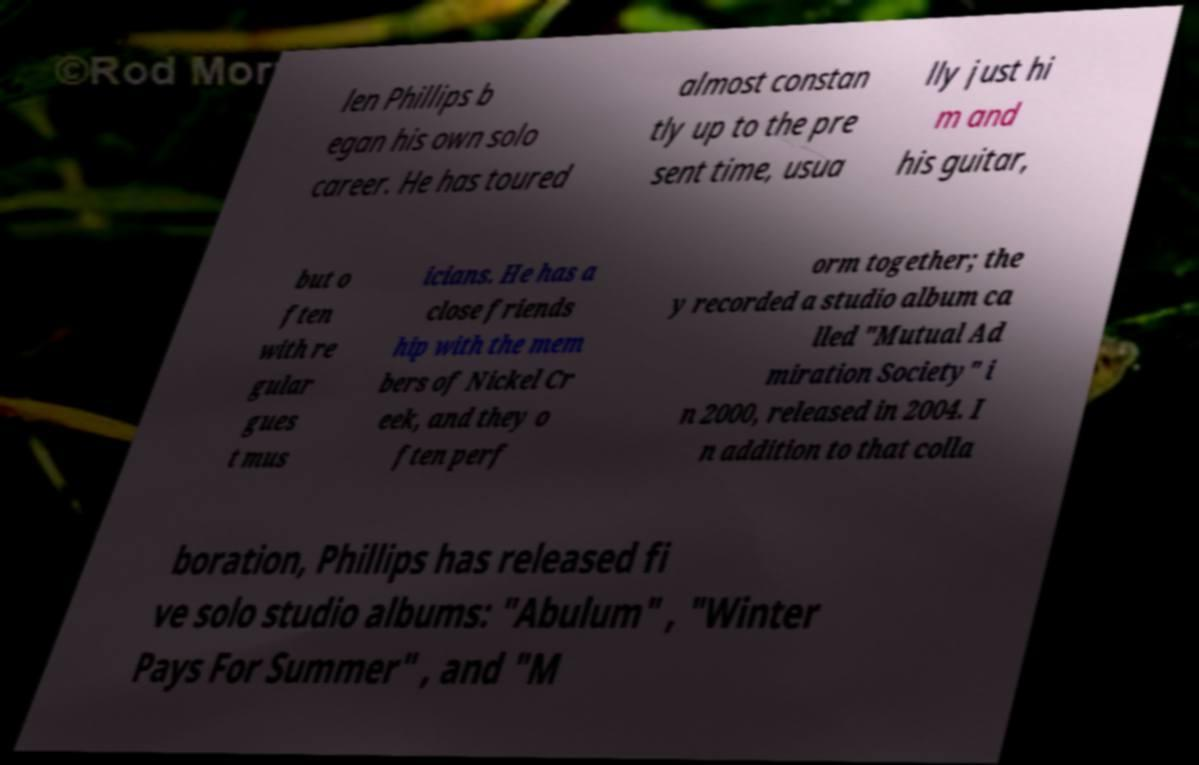What messages or text are displayed in this image? I need them in a readable, typed format. len Phillips b egan his own solo career. He has toured almost constan tly up to the pre sent time, usua lly just hi m and his guitar, but o ften with re gular gues t mus icians. He has a close friends hip with the mem bers of Nickel Cr eek, and they o ften perf orm together; the y recorded a studio album ca lled "Mutual Ad miration Society" i n 2000, released in 2004. I n addition to that colla boration, Phillips has released fi ve solo studio albums: "Abulum" , "Winter Pays For Summer" , and "M 